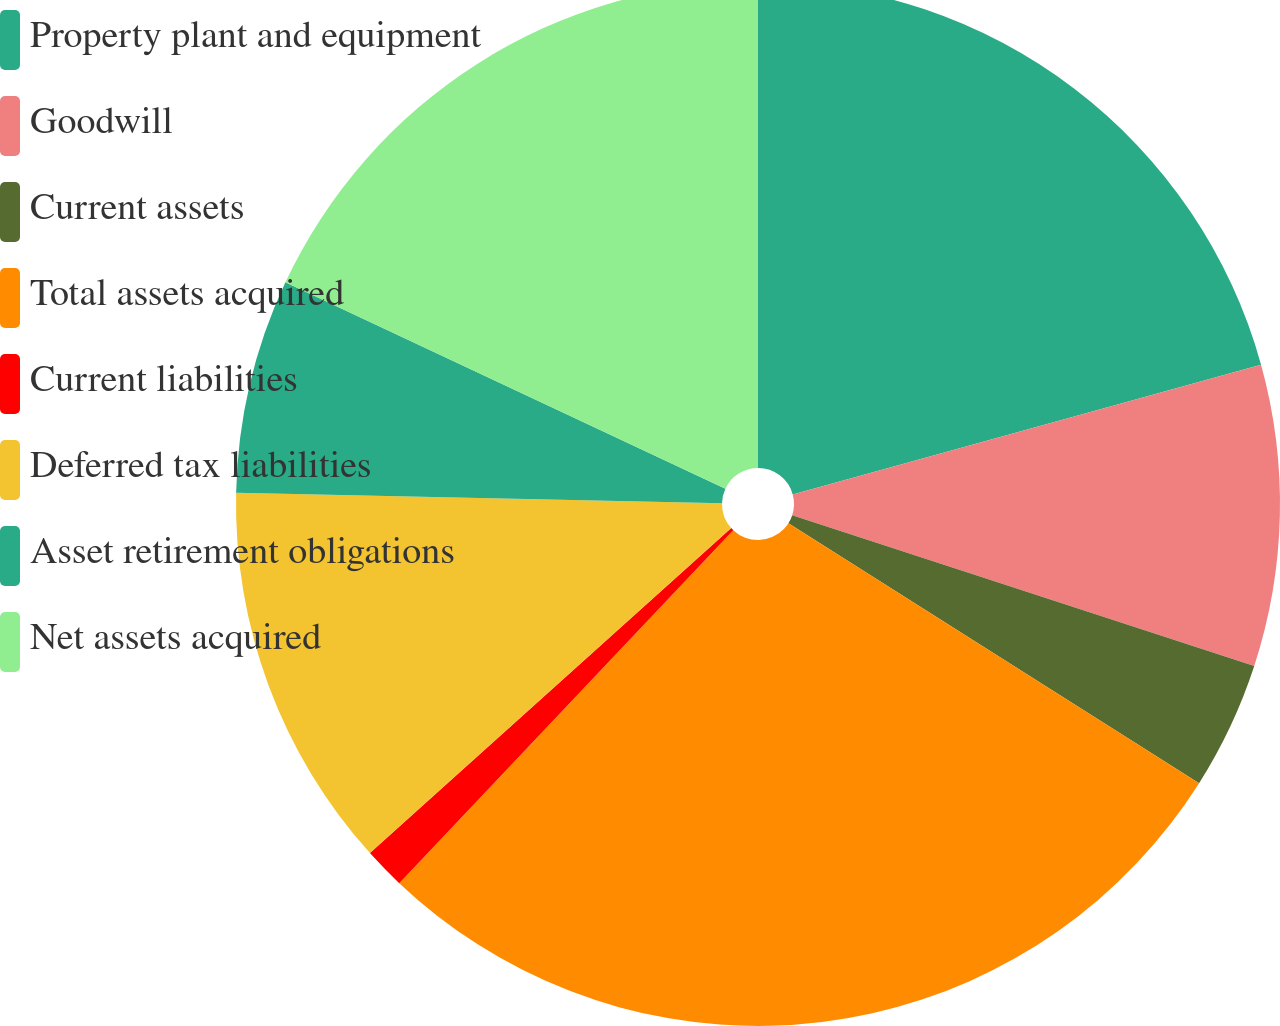<chart> <loc_0><loc_0><loc_500><loc_500><pie_chart><fcel>Property plant and equipment<fcel>Goodwill<fcel>Current assets<fcel>Total assets acquired<fcel>Current liabilities<fcel>Deferred tax liabilities<fcel>Asset retirement obligations<fcel>Net assets acquired<nl><fcel>20.7%<fcel>9.32%<fcel>3.96%<fcel>28.08%<fcel>1.28%<fcel>12.0%<fcel>6.64%<fcel>18.02%<nl></chart> 